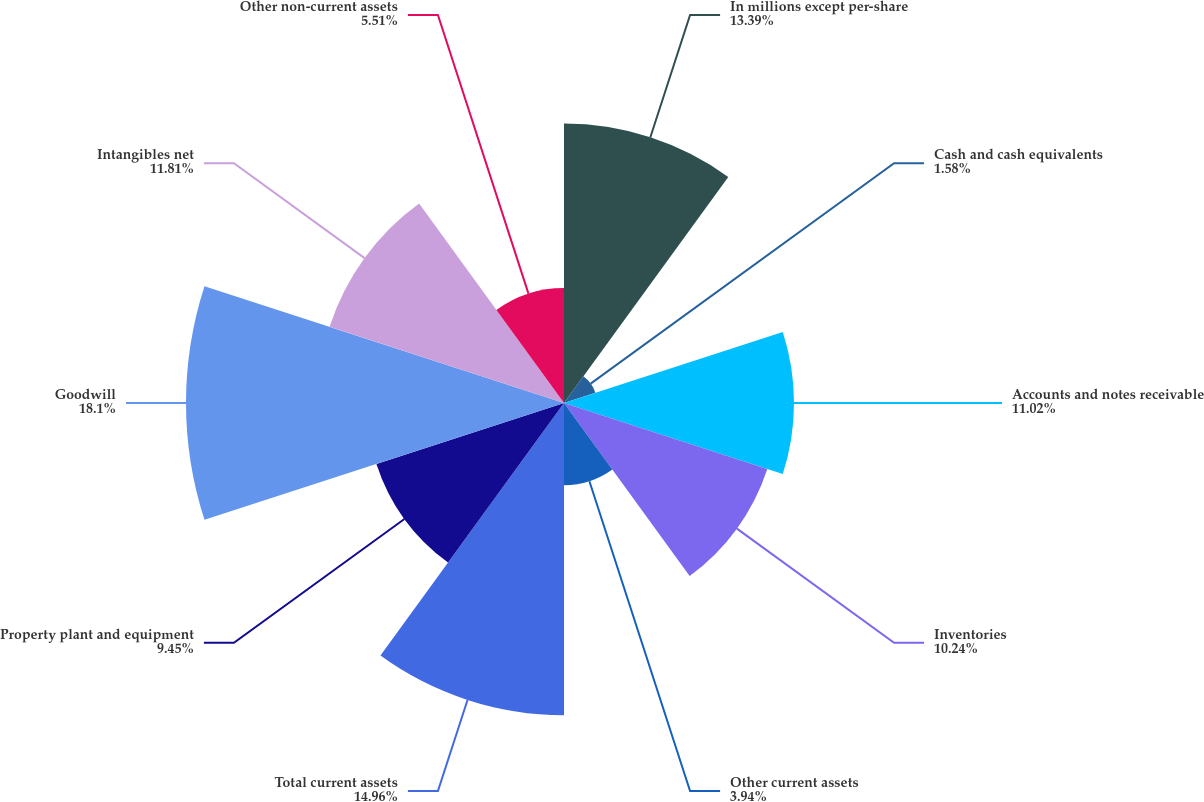Convert chart. <chart><loc_0><loc_0><loc_500><loc_500><pie_chart><fcel>In millions except per-share<fcel>Cash and cash equivalents<fcel>Accounts and notes receivable<fcel>Inventories<fcel>Other current assets<fcel>Total current assets<fcel>Property plant and equipment<fcel>Goodwill<fcel>Intangibles net<fcel>Other non-current assets<nl><fcel>13.39%<fcel>1.58%<fcel>11.02%<fcel>10.24%<fcel>3.94%<fcel>14.96%<fcel>9.45%<fcel>18.11%<fcel>11.81%<fcel>5.51%<nl></chart> 